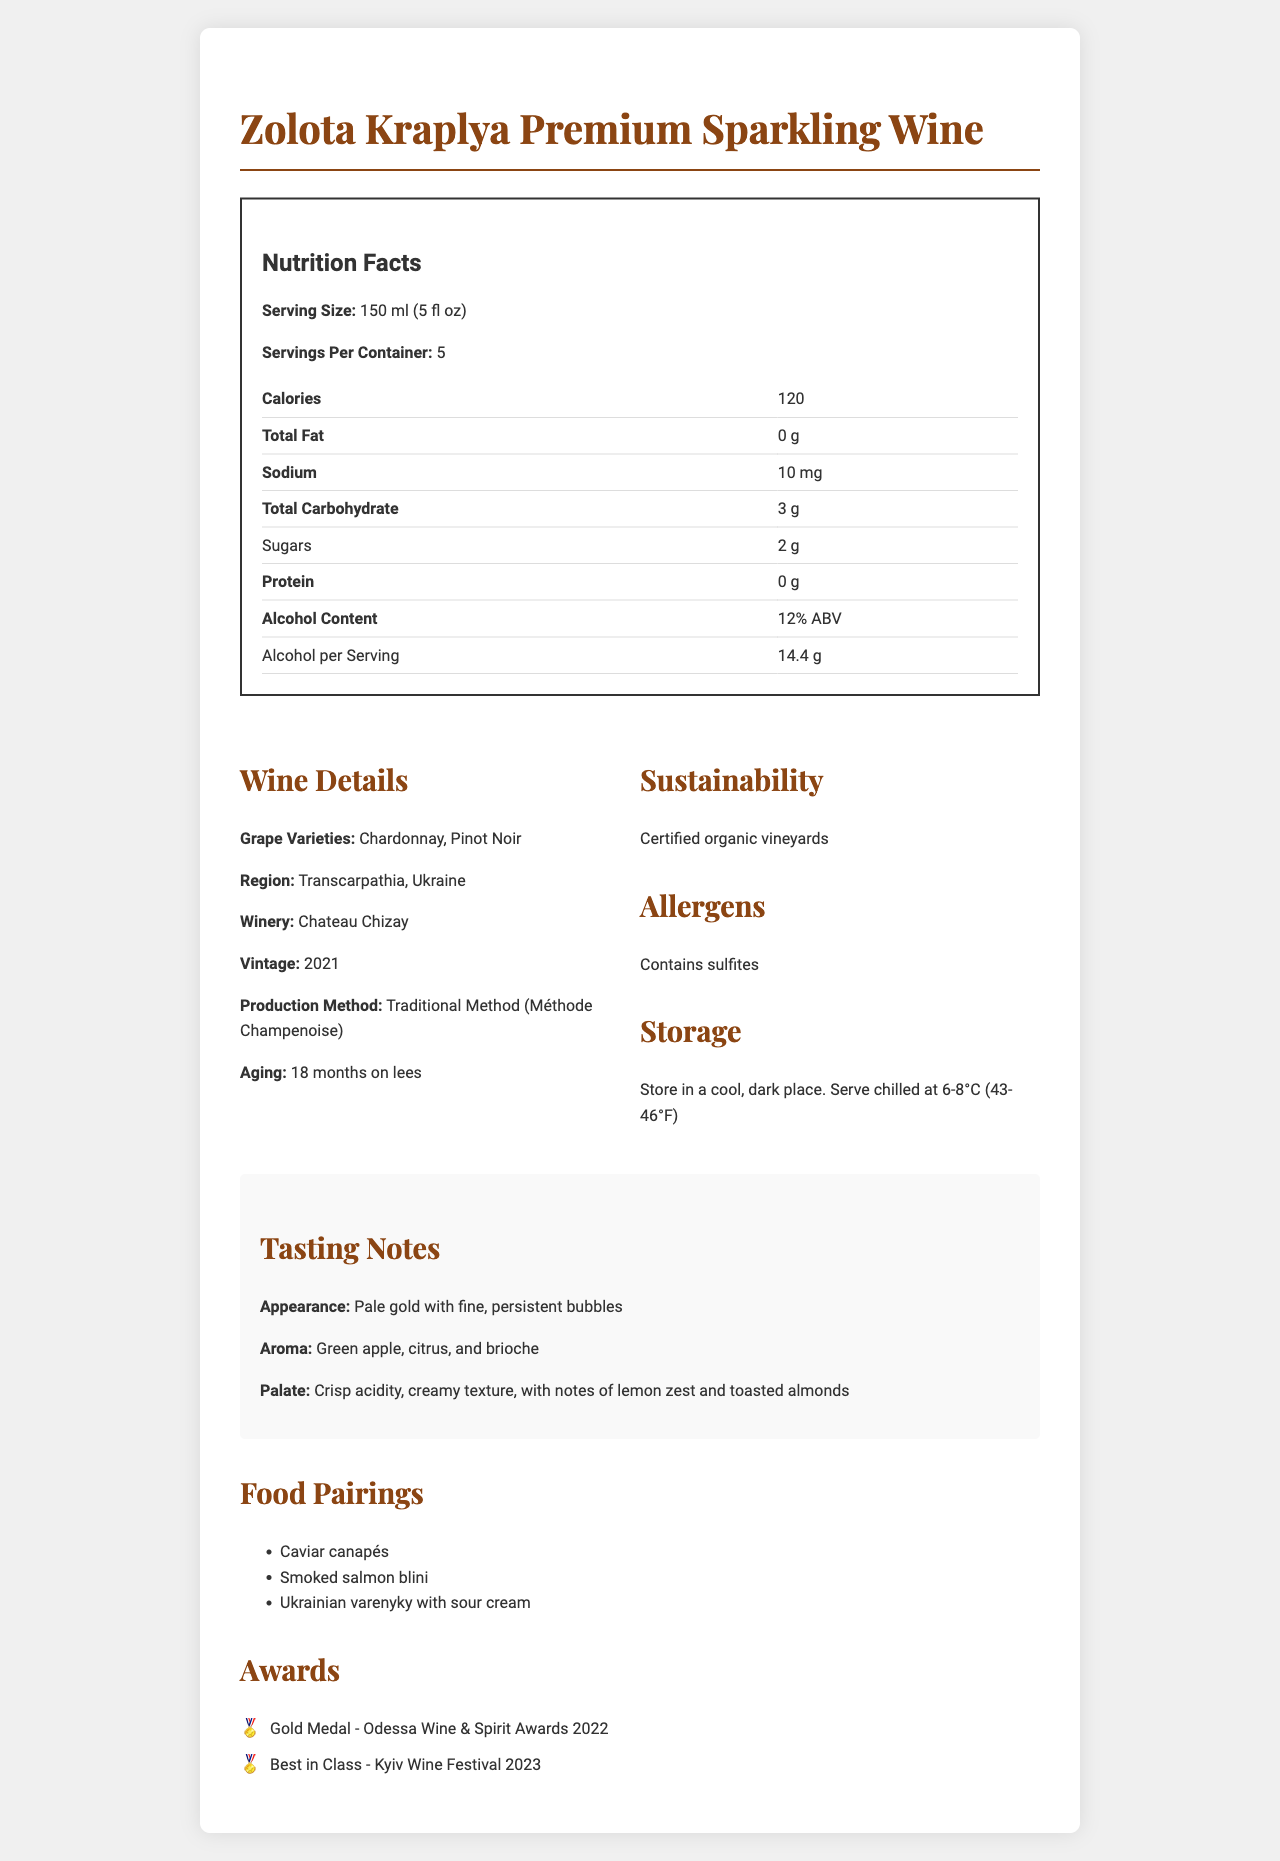what is the serving size for Zolota Kraplya Premium Sparkling Wine? The serving size is listed as "150 ml (5 fl oz)" in the Nutrition Facts section.
Answer: 150 ml (5 fl oz) how many servings are there per container? The document specifies that there are 5 servings per container.
Answer: 5 how many calories are in a serving of Zolota Kraplya Premium Sparkling Wine? The document lists the calorie content as 120 per serving.
Answer: 120 what is the alcohol content by volume? The alcohol content by volume is listed as "12% ABV" in the Nutrition Facts section.
Answer: 12% ABV what are the grape varieties used in this wine? The wine is made from Chardonnay and Pinot Noir grape varieties, as mentioned in the Wine Details section.
Answer: Chardonnay, Pinot Noir what type of medals has Zolota Kraplya Premium Sparkling Wine won? The Awards section lists these two medals.
Answer: Gold Medal at the Odessa Wine & Spirit Awards 2022 and Best in Class at the Kyiv Wine Festival 2023 how should Zolota Kraplya Premium Sparkling Wine be stored? The document provides storage instructions in the Storage section.
Answer: Store in a cool, dark place. Serve chilled at 6-8°C (43-46°F) which region is the wine from? A. Transcarpathia B. Crimea C. Odessa The wine is from the Transcarpathia region, as mentioned in the Wine Details section.
Answer: A. Transcarpathia what is the aging period for Zolota Kraplya Premium Sparkling Wine? A. 12 months B. 18 months C. 24 months The wine is aged 18 months on lees, as described in the Wine Details section.
Answer: B. 18 months is this wine suitable for consumers who are allergic to sulfites? The Allergens section states that the wine contains sulfites.
Answer: No are sulfites present in Zolota Kraplya Premium Sparkling Wine? The document states in the Allergens section that the wine contains sulfites.
Answer: Yes describe the appearance of Zolota Kraplya Premium Sparkling Wine. The Tasting Notes section describes the appearance as "Pale gold with fine, persistent bubbles."
Answer: Pale gold with fine, persistent bubbles cannot be answered: how many bottles are produced annually? The document does not provide any information regarding the annual production quantity.
Answer: Not enough information explain the main idea of the document. The document is a comprehensive guide detailing the nutritional content, wine characteristics, and accolades of Zolota Kraplya Premium Sparkling Wine, highlighting its premium nature and the best ways to enjoy and store it.
Answer: The document provides detailed nutritional information, wine specifics, tasting notes, awards, sustainability details, allergens, and storage instructions for Zolota Kraplya Premium Sparkling Wine. 